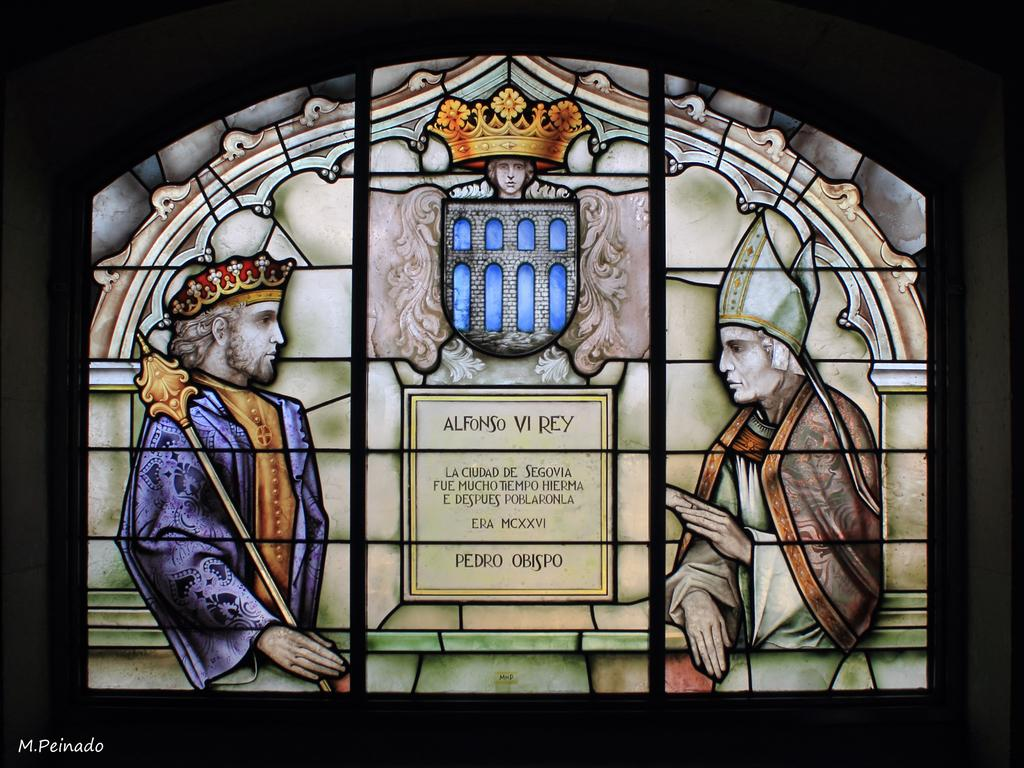<image>
Relay a brief, clear account of the picture shown. A window made of mosaic art depicts a king speaking with a holy and man has the name Alfonso Vi Rey in between them, just above a passage of text. 